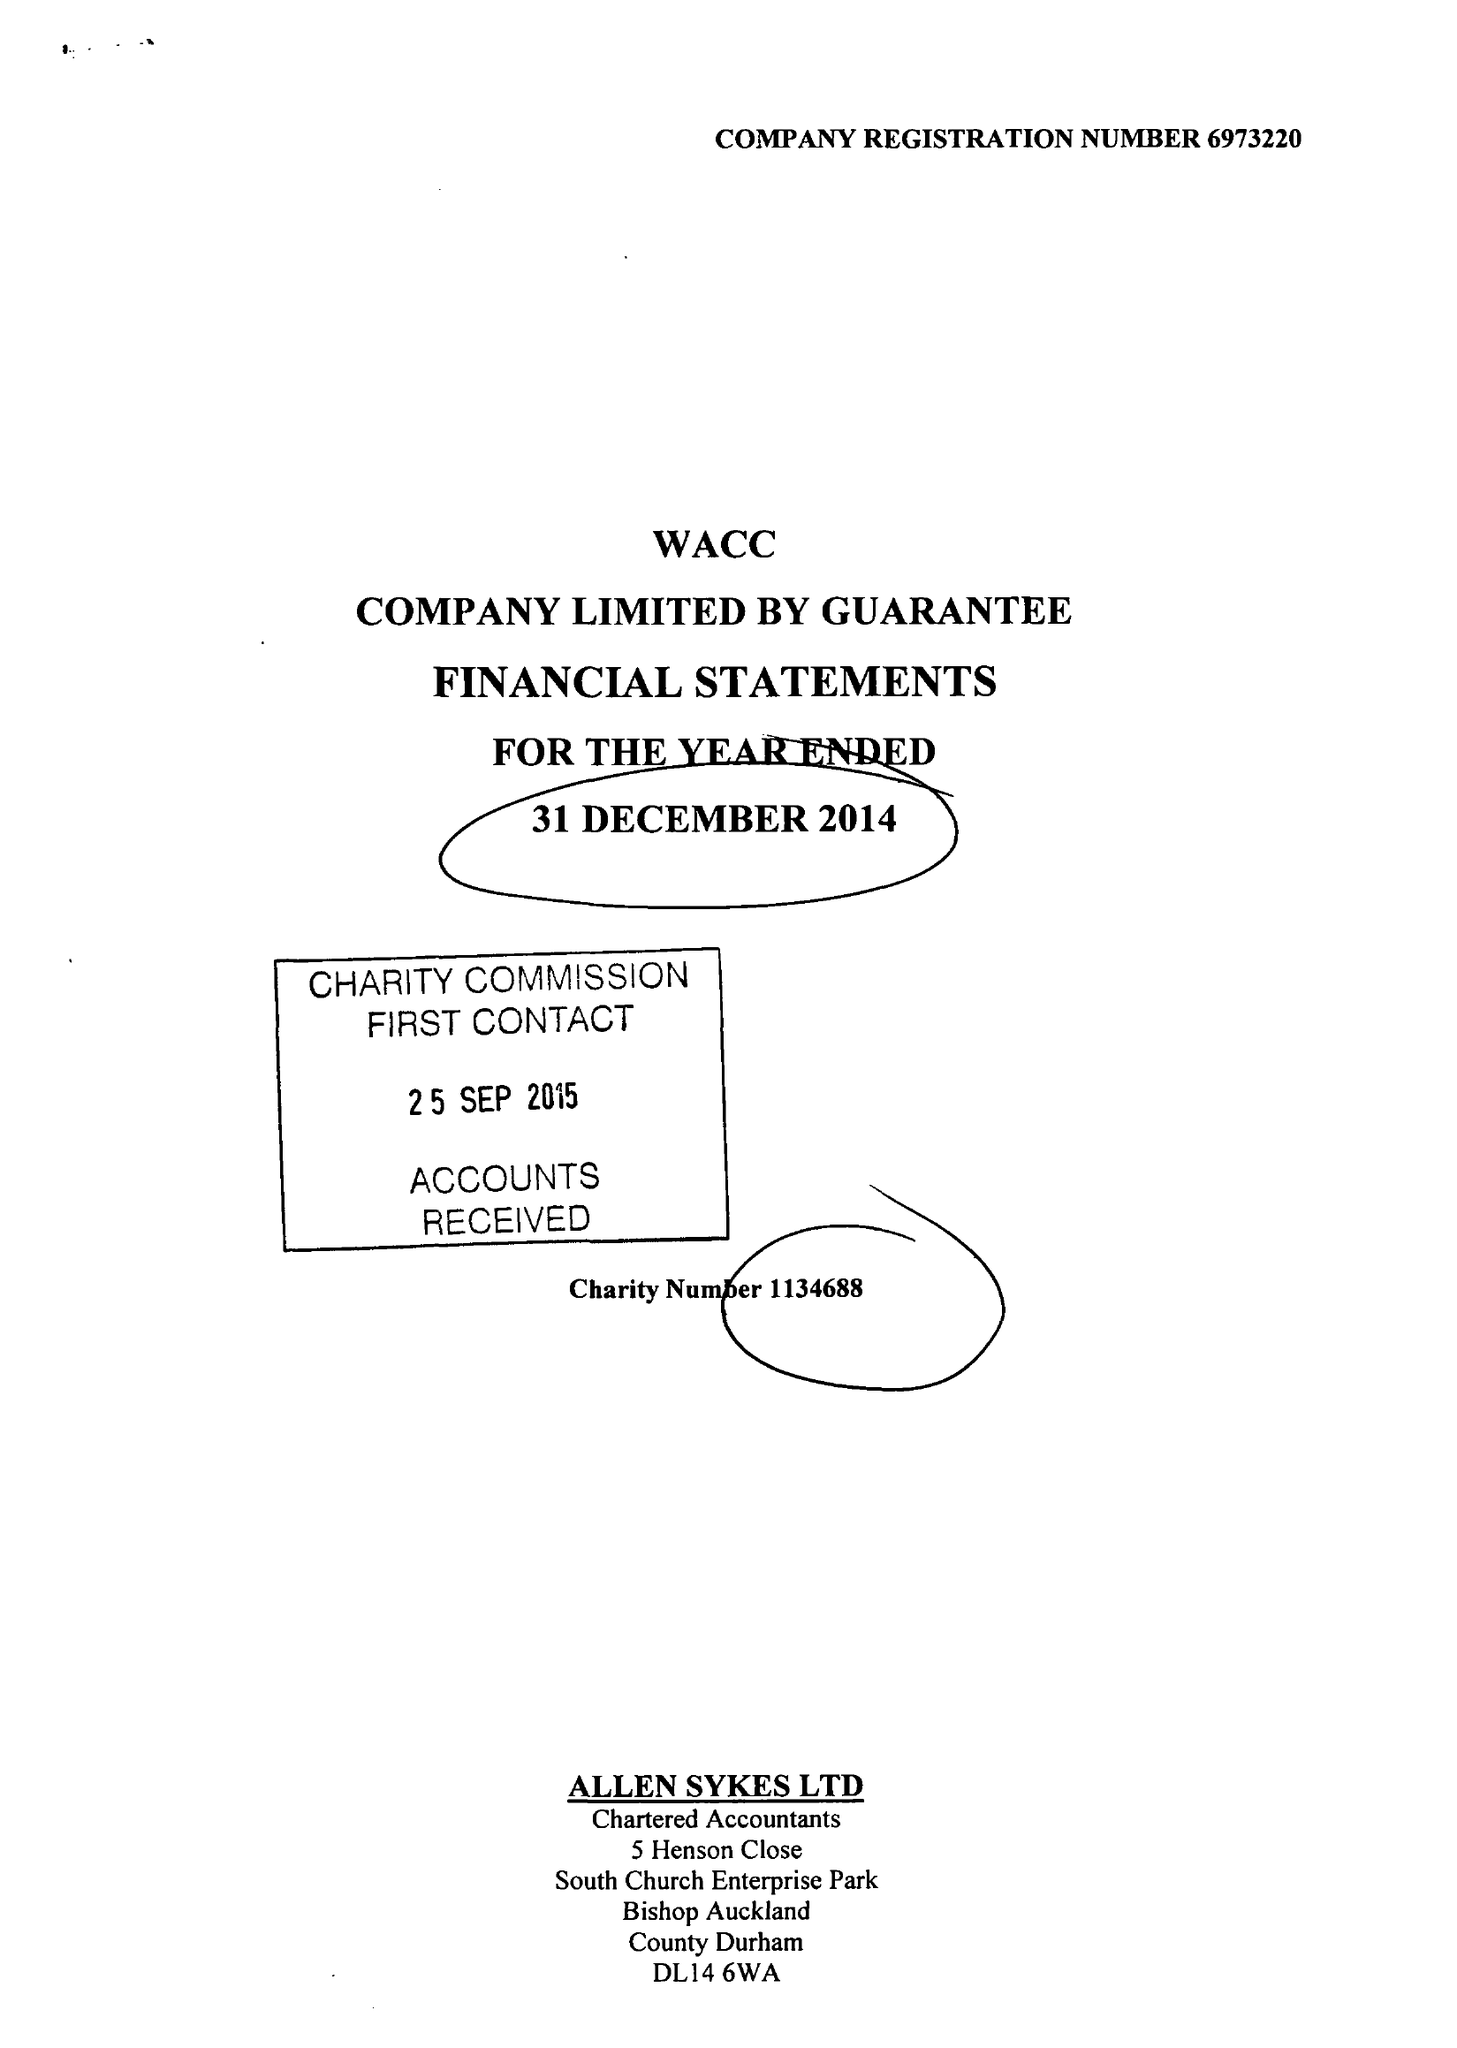What is the value for the address__post_town?
Answer the question using a single word or phrase. BISHOP AUCKLAND 